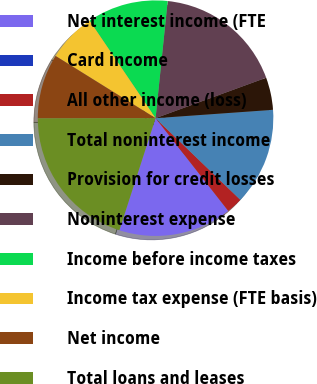Convert chart. <chart><loc_0><loc_0><loc_500><loc_500><pie_chart><fcel>Net interest income (FTE<fcel>Card income<fcel>All other income (loss)<fcel>Total noninterest income<fcel>Provision for credit losses<fcel>Noninterest expense<fcel>Income before income taxes<fcel>Income tax expense (FTE basis)<fcel>Net income<fcel>Total loans and leases<nl><fcel>15.55%<fcel>0.0%<fcel>2.22%<fcel>13.33%<fcel>4.45%<fcel>17.78%<fcel>11.11%<fcel>6.67%<fcel>8.89%<fcel>20.0%<nl></chart> 